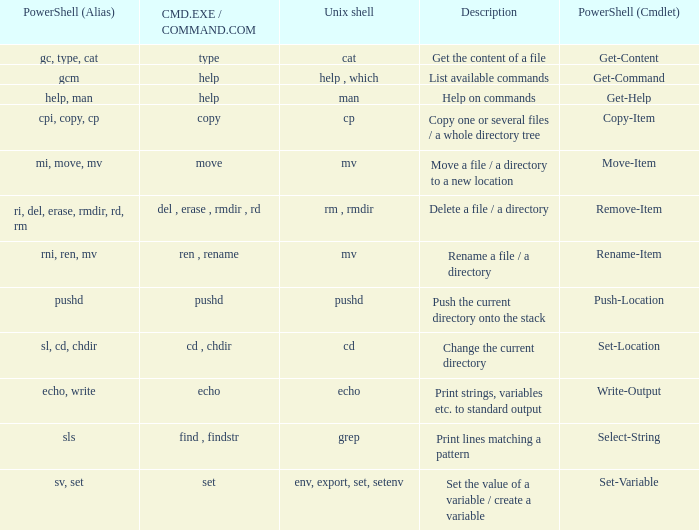What are all values of CMD.EXE / COMMAND.COM for the unix shell echo? Echo. Can you parse all the data within this table? {'header': ['PowerShell (Alias)', 'CMD.EXE / COMMAND.COM', 'Unix shell', 'Description', 'PowerShell (Cmdlet)'], 'rows': [['gc, type, cat', 'type', 'cat', 'Get the content of a file', 'Get-Content'], ['gcm', 'help', 'help , which', 'List available commands', 'Get-Command'], ['help, man', 'help', 'man', 'Help on commands', 'Get-Help'], ['cpi, copy, cp', 'copy', 'cp', 'Copy one or several files / a whole directory tree', 'Copy-Item'], ['mi, move, mv', 'move', 'mv', 'Move a file / a directory to a new location', 'Move-Item'], ['ri, del, erase, rmdir, rd, rm', 'del , erase , rmdir , rd', 'rm , rmdir', 'Delete a file / a directory', 'Remove-Item'], ['rni, ren, mv', 'ren , rename', 'mv', 'Rename a file / a directory', 'Rename-Item'], ['pushd', 'pushd', 'pushd', 'Push the current directory onto the stack', 'Push-Location'], ['sl, cd, chdir', 'cd , chdir', 'cd', 'Change the current directory', 'Set-Location'], ['echo, write', 'echo', 'echo', 'Print strings, variables etc. to standard output', 'Write-Output'], ['sls', 'find , findstr', 'grep', 'Print lines matching a pattern', 'Select-String'], ['sv, set', 'set', 'env, export, set, setenv', 'Set the value of a variable / create a variable', 'Set-Variable']]} 